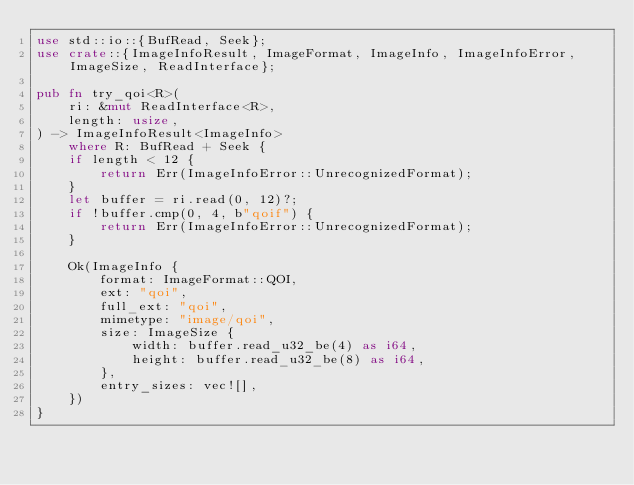Convert code to text. <code><loc_0><loc_0><loc_500><loc_500><_Rust_>use std::io::{BufRead, Seek};
use crate::{ImageInfoResult, ImageFormat, ImageInfo, ImageInfoError, ImageSize, ReadInterface};

pub fn try_qoi<R>(
    ri: &mut ReadInterface<R>,
    length: usize,
) -> ImageInfoResult<ImageInfo>
    where R: BufRead + Seek {
    if length < 12 {
        return Err(ImageInfoError::UnrecognizedFormat);
    }
    let buffer = ri.read(0, 12)?;
    if !buffer.cmp(0, 4, b"qoif") {
        return Err(ImageInfoError::UnrecognizedFormat);
    }

    Ok(ImageInfo {
        format: ImageFormat::QOI,
        ext: "qoi",
        full_ext: "qoi",
        mimetype: "image/qoi",
        size: ImageSize {
            width: buffer.read_u32_be(4) as i64,
            height: buffer.read_u32_be(8) as i64,
        },
        entry_sizes: vec![],
    })
}

</code> 